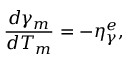Convert formula to latex. <formula><loc_0><loc_0><loc_500><loc_500>\frac { d \gamma _ { m } } { d T _ { m } } = - \eta _ { \gamma } ^ { e } ,</formula> 